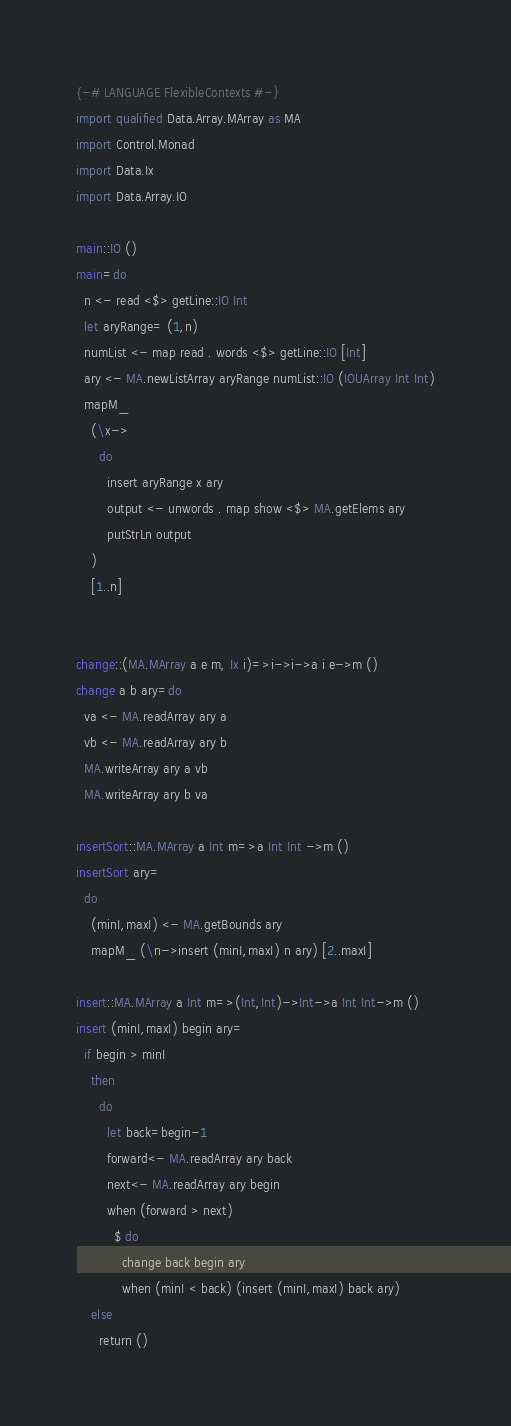<code> <loc_0><loc_0><loc_500><loc_500><_Haskell_>{-# LANGUAGE FlexibleContexts #-}
import qualified Data.Array.MArray as MA
import Control.Monad
import Data.Ix
import Data.Array.IO

main::IO ()
main=do
  n <- read <$> getLine::IO Int
  let aryRange= (1,n)
  numList <- map read . words <$> getLine::IO [Int]
  ary <- MA.newListArray aryRange numList::IO (IOUArray Int Int)
  mapM_
    (\x->
      do
        insert aryRange x ary
        output <- unwords . map show <$> MA.getElems ary
        putStrLn output
    )
    [1..n]


change::(MA.MArray a e m, Ix i)=>i->i->a i e->m ()
change a b ary=do
  va <- MA.readArray ary a
  vb <- MA.readArray ary b
  MA.writeArray ary a vb
  MA.writeArray ary b va

insertSort::MA.MArray a Int m=>a Int Int ->m ()
insertSort ary=
  do
    (minI,maxI) <- MA.getBounds ary
    mapM_ (\n->insert (minI,maxI) n ary) [2..maxI]

insert::MA.MArray a Int m=>(Int,Int)->Int->a Int Int->m ()
insert (minI,maxI) begin ary=
  if begin > minI
    then
      do
        let back=begin-1
        forward<- MA.readArray ary back
        next<- MA.readArray ary begin
        when (forward > next)
          $ do
            change back begin ary
            when (minI < back) (insert (minI,maxI) back ary)
    else
      return ()</code> 